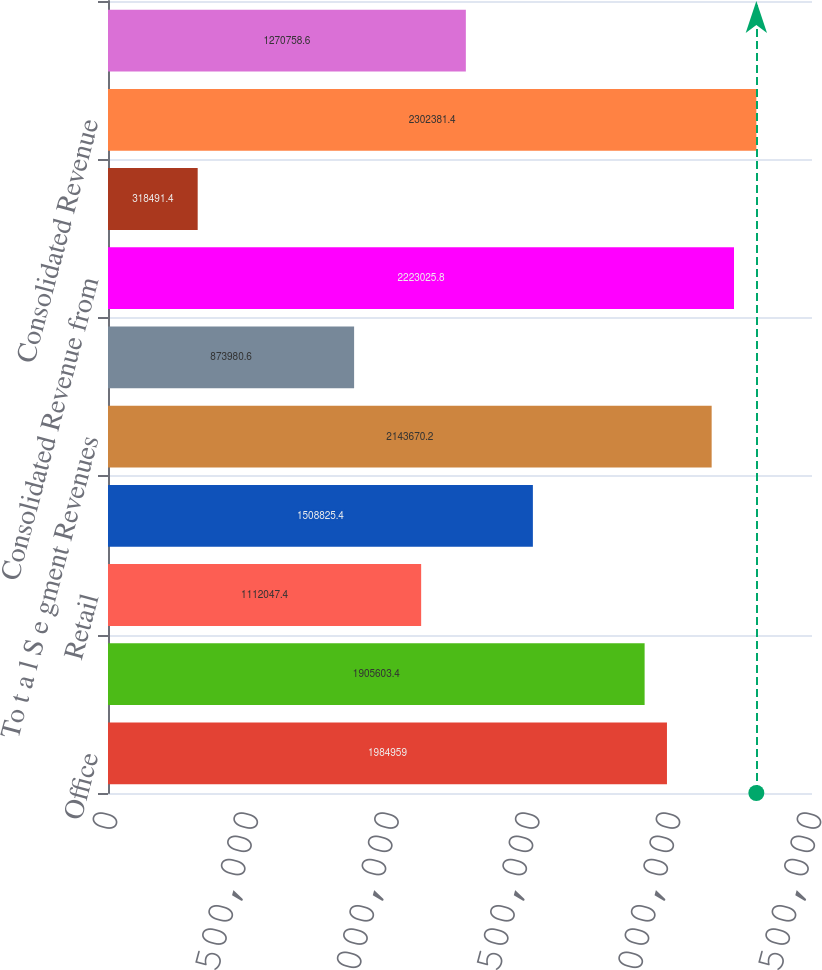Convert chart. <chart><loc_0><loc_0><loc_500><loc_500><bar_chart><fcel>Office<fcel>Industrial<fcel>Retail<fcel>Service Operations<fcel>To t a l S e gment Revenues<fcel>Non-Segment Revenue<fcel>Consolidated Revenue from<fcel>Discontinued Operations<fcel>Consolidated Revenue<fcel>Services Operations<nl><fcel>1.98496e+06<fcel>1.9056e+06<fcel>1.11205e+06<fcel>1.50883e+06<fcel>2.14367e+06<fcel>873981<fcel>2.22303e+06<fcel>318491<fcel>2.30238e+06<fcel>1.27076e+06<nl></chart> 